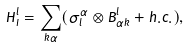<formula> <loc_0><loc_0><loc_500><loc_500>\tilde { H } _ { I } ^ { l } = \sum _ { k \alpha } ( \sigma ^ { \alpha } _ { l } \otimes B _ { \alpha k } ^ { l } + h . c . ) ,</formula> 